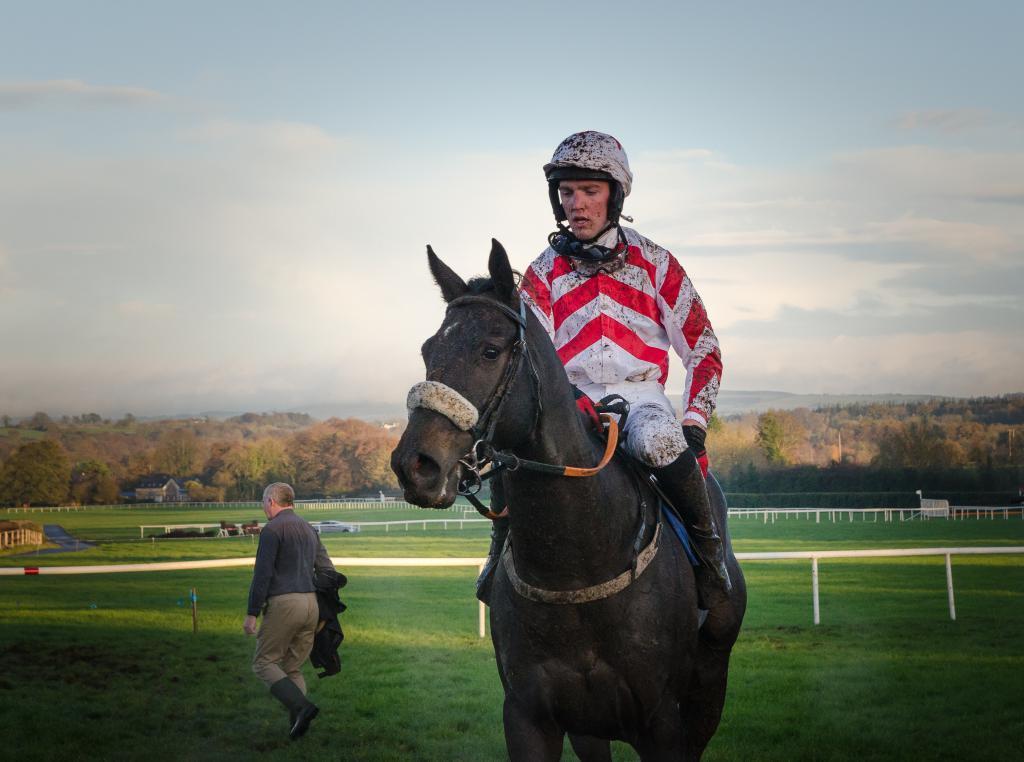Please provide a concise description of this image. There are two people. In the center person is sitting on a horse. On the left side we have a another person. He's walking like slowly. We can see in the background there is a tree and sky. 